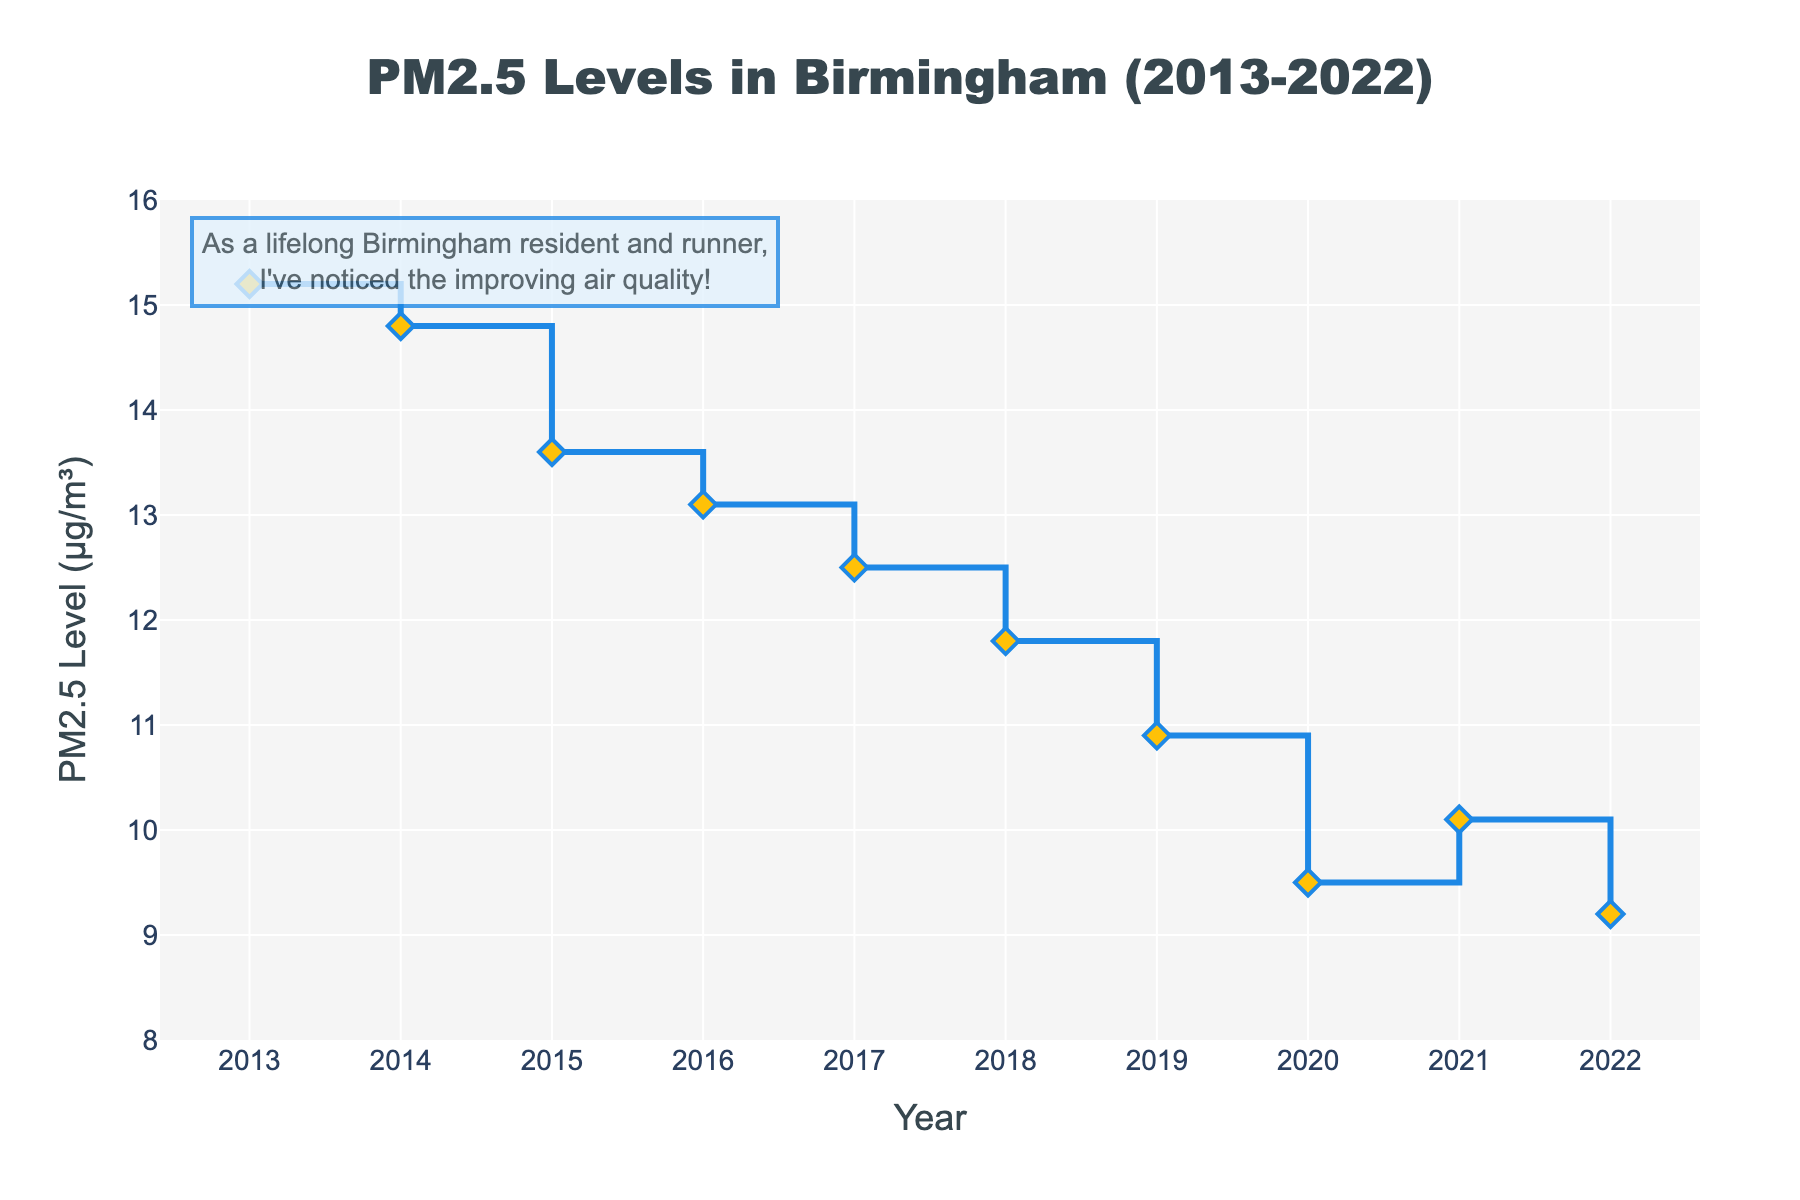What is the trend in PM2.5 levels in Birmingham from 2013 to 2022? The PM2.5 levels show a general decreasing trend from 2013 to 2022, with some minor fluctuations. The levels drop from 15.2 µg/m³ in 2013 to 9.2 µg/m³ in 2022.
Answer: Decreasing trend How many years saw a decrease in PM2.5 levels compared to the previous year? To find this, count the years where the PM2.5 level is lower than the previous year: 2014, 2015, 2016, 2017, 2018, 2019, 2020, and 2022. There are 8 such years.
Answer: 8 Which year had the highest PM2.5 level and what was the value? By inspecting the highest point in the figure, you can see that the year 2013 had the highest PM2.5 level at 15.2 µg/m³.
Answer: 2013, 15.2 µg/m³ What is the difference in PM2.5 levels between 2013 and 2022? Subtract the PM2.5 level in 2022 from the level in 2013: 15.2 - 9.2 = 6.0 µg/m³.
Answer: 6.0 µg/m³ What is the average PM2.5 level over the entire period shown? Calculate the average by summing all the PM2.5 levels and dividing by the number of years: (15.2 + 14.8 + 13.6 + 13.1 + 12.5 + 11.8 + 10.9 + 9.5 + 10.1 + 9.2) / 10 = 12.07 µg/m³.
Answer: 12.07 µg/m³ In which year was there a slight increase in PM2.5 levels compared to the previous year? By looking at the plot, you can see that the year 2021 saw an increase in PM2.5 levels compared to the previous year, from 9.5 µg/m³ to 10.1 µg/m³.
Answer: 2021 Which three consecutive years show the steepest decrease in PM2.5 levels? To find this, compare the differences for consecutive years: The steepest decrease occurs from 2018 to 2020 (11.8 to 9.5 µg/m³). The three consecutive years here are 2018, 2019, and 2020.
Answer: 2018-2020 What is the median PM2.5 level over the decade? Arrange the PM2.5 levels in ascending order and find the middle value(s). The PM2.5 levels are: [9.2, 9.5, 10.1, 10.9, 11.8, 12.5, 13.1, 13.6, 14.8, 15.2]. The median is the average of the 5th and 6th values: (11.8 + 12.5) / 2 = 12.15 µg/m³.
Answer: 12.15 µg/m³ 